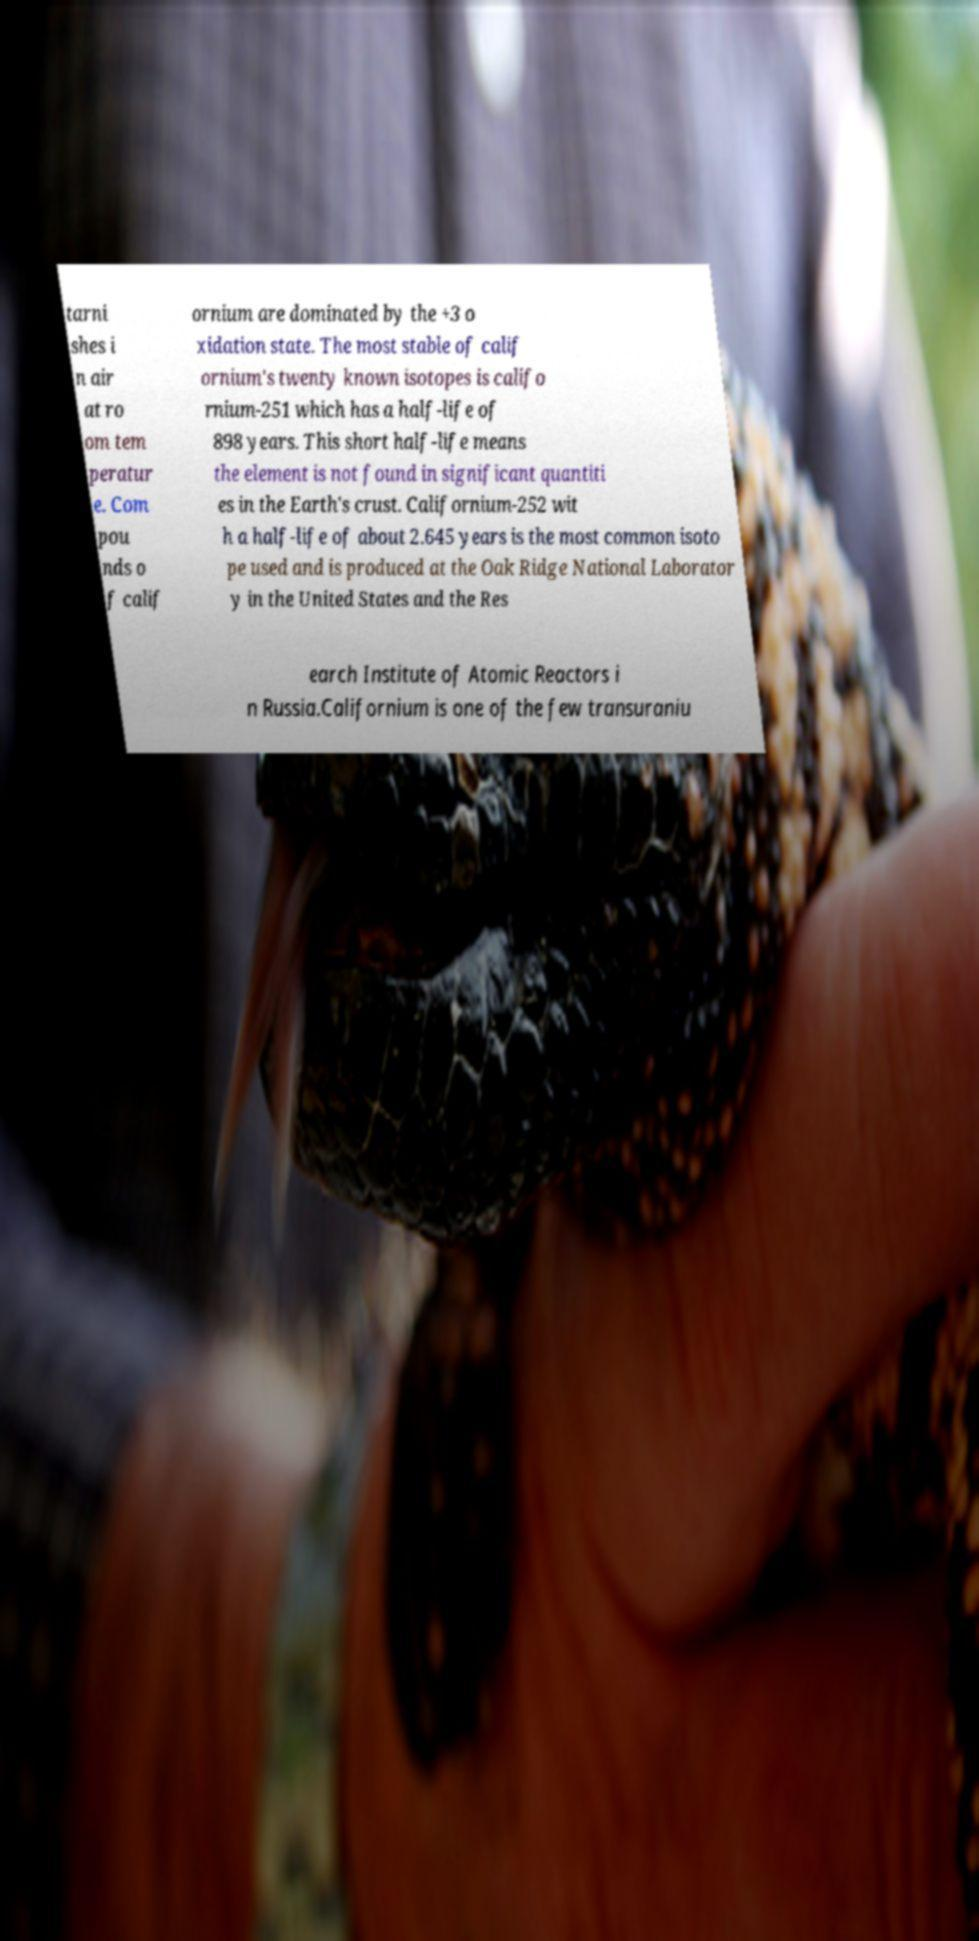Could you extract and type out the text from this image? tarni shes i n air at ro om tem peratur e. Com pou nds o f calif ornium are dominated by the +3 o xidation state. The most stable of calif ornium's twenty known isotopes is califo rnium-251 which has a half-life of 898 years. This short half-life means the element is not found in significant quantiti es in the Earth's crust. Californium-252 wit h a half-life of about 2.645 years is the most common isoto pe used and is produced at the Oak Ridge National Laborator y in the United States and the Res earch Institute of Atomic Reactors i n Russia.Californium is one of the few transuraniu 